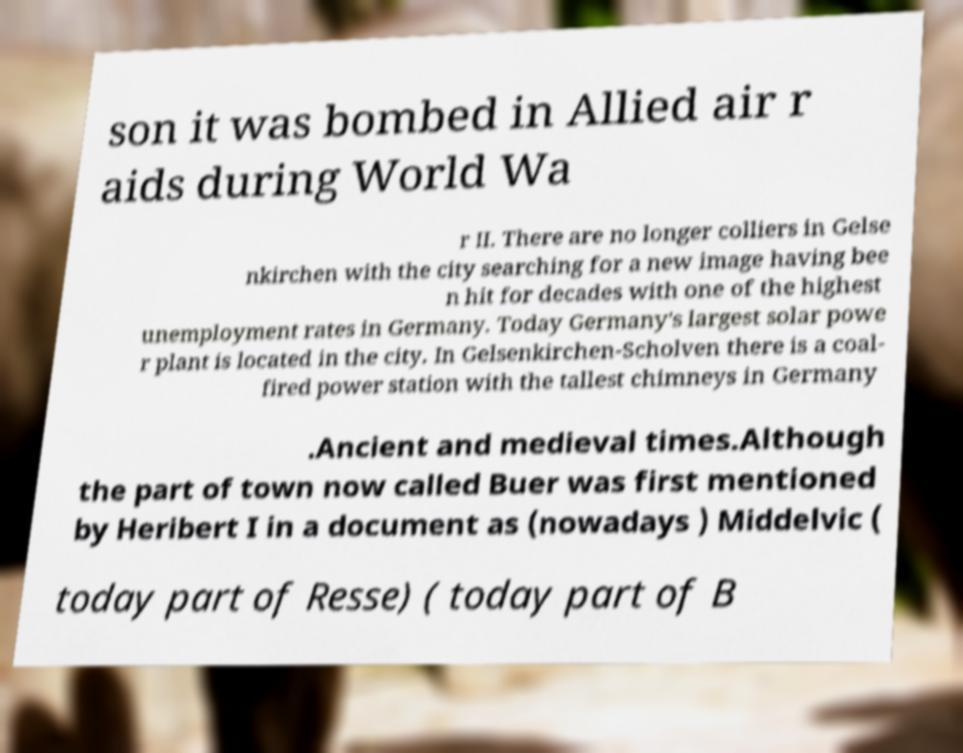Please identify and transcribe the text found in this image. son it was bombed in Allied air r aids during World Wa r II. There are no longer colliers in Gelse nkirchen with the city searching for a new image having bee n hit for decades with one of the highest unemployment rates in Germany. Today Germany's largest solar powe r plant is located in the city. In Gelsenkirchen-Scholven there is a coal- fired power station with the tallest chimneys in Germany .Ancient and medieval times.Although the part of town now called Buer was first mentioned by Heribert I in a document as (nowadays ) Middelvic ( today part of Resse) ( today part of B 